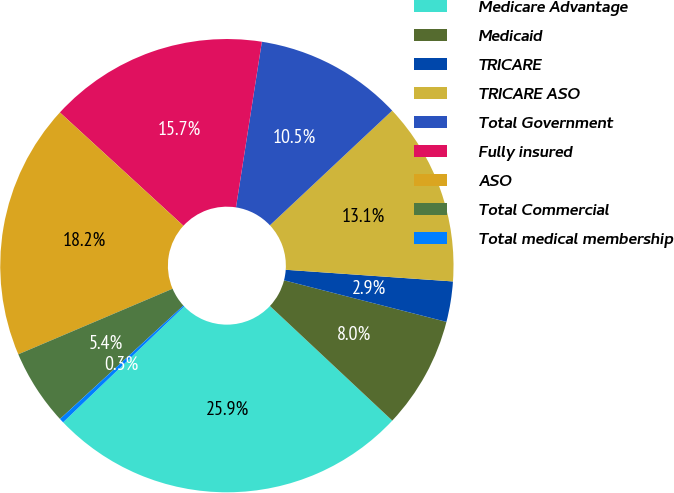Convert chart to OTSL. <chart><loc_0><loc_0><loc_500><loc_500><pie_chart><fcel>Medicare Advantage<fcel>Medicaid<fcel>TRICARE<fcel>TRICARE ASO<fcel>Total Government<fcel>Fully insured<fcel>ASO<fcel>Total Commercial<fcel>Total medical membership<nl><fcel>25.87%<fcel>7.99%<fcel>2.88%<fcel>13.1%<fcel>10.54%<fcel>15.65%<fcel>18.21%<fcel>5.43%<fcel>0.32%<nl></chart> 